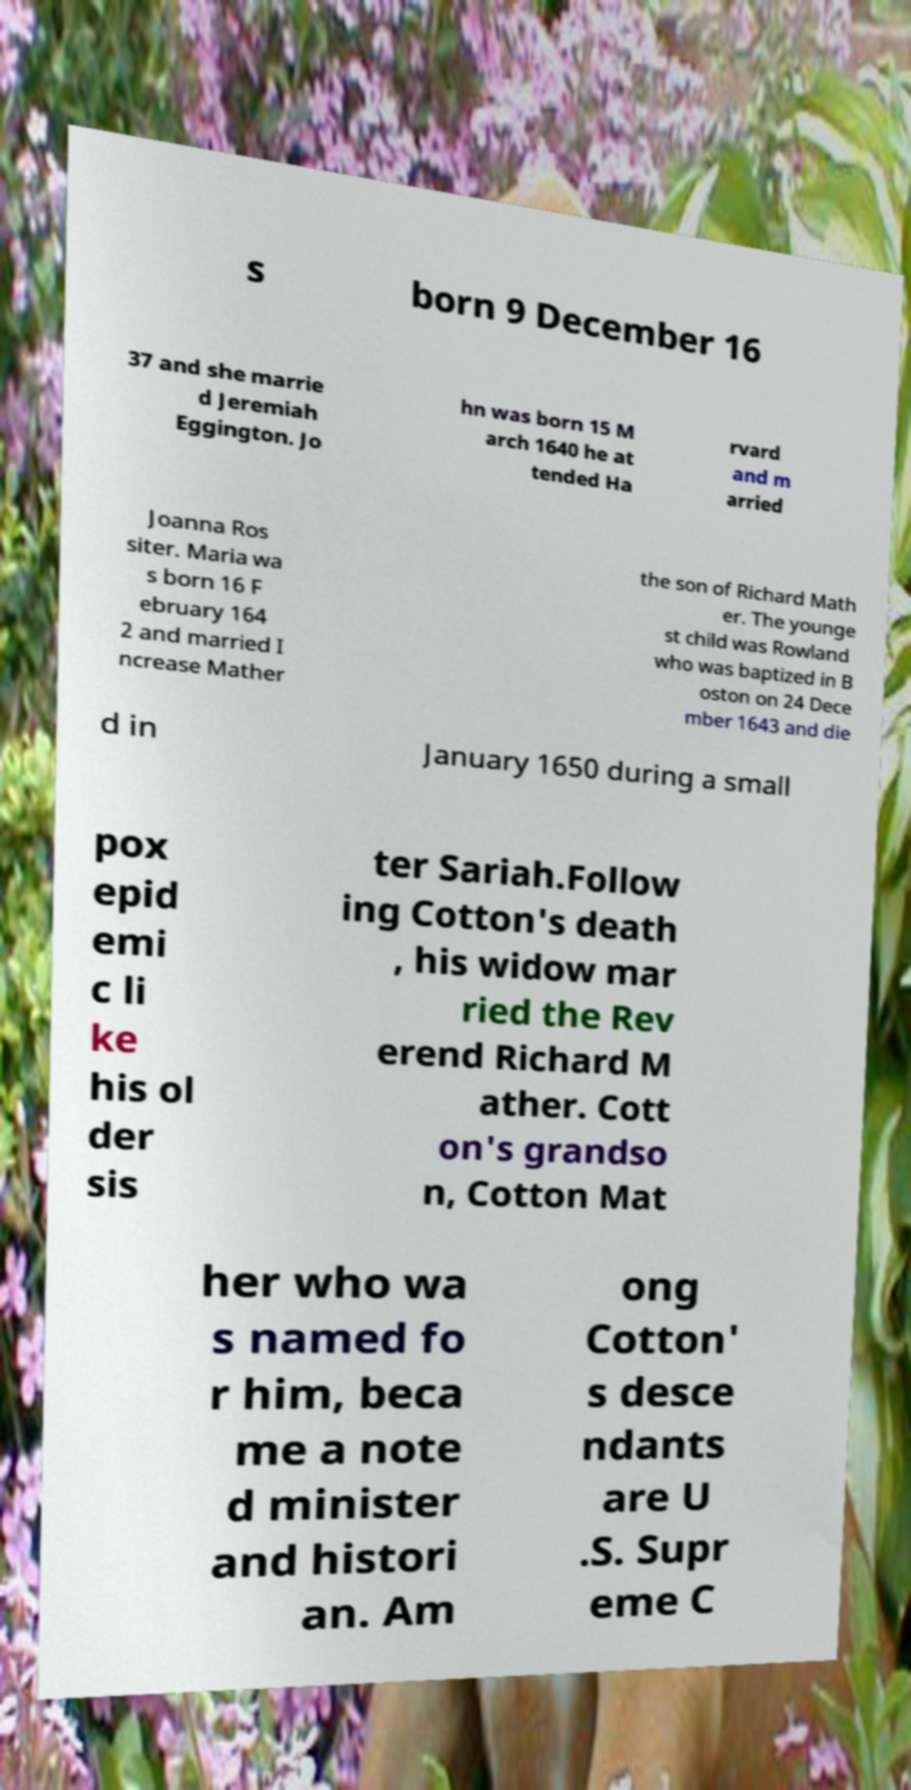I need the written content from this picture converted into text. Can you do that? s born 9 December 16 37 and she marrie d Jeremiah Eggington. Jo hn was born 15 M arch 1640 he at tended Ha rvard and m arried Joanna Ros siter. Maria wa s born 16 F ebruary 164 2 and married I ncrease Mather the son of Richard Math er. The younge st child was Rowland who was baptized in B oston on 24 Dece mber 1643 and die d in January 1650 during a small pox epid emi c li ke his ol der sis ter Sariah.Follow ing Cotton's death , his widow mar ried the Rev erend Richard M ather. Cott on's grandso n, Cotton Mat her who wa s named fo r him, beca me a note d minister and histori an. Am ong Cotton' s desce ndants are U .S. Supr eme C 